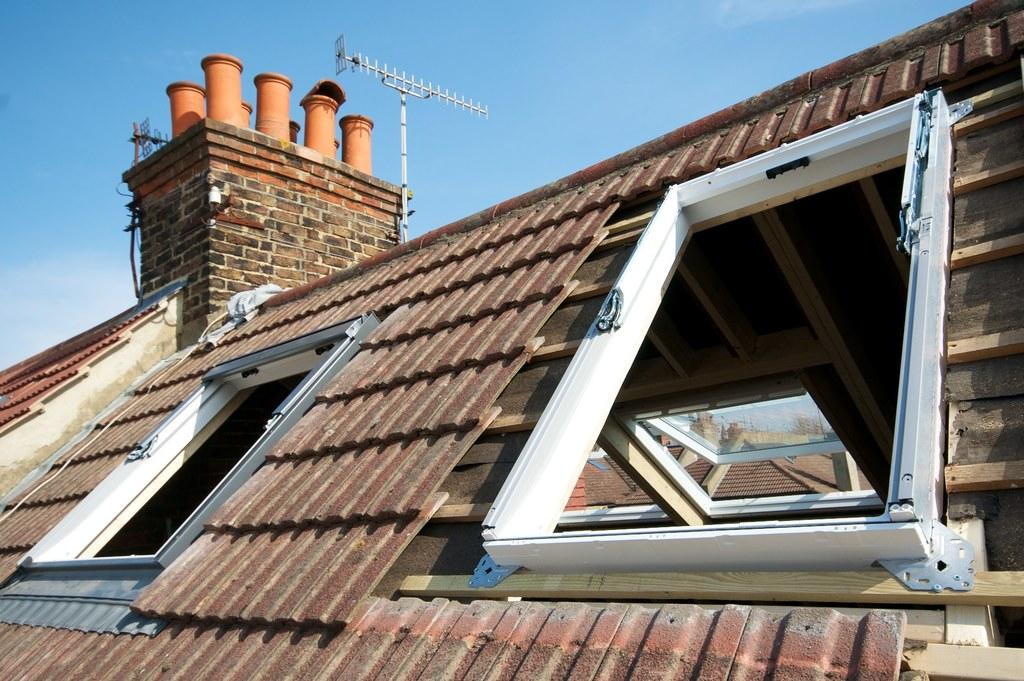What type of structures are present in the image? There are buildings in the image. What feature can be observed on the buildings? The buildings have glass windows. What additional object is present in the image? There is an antenna in the image. What can be seen in the background of the image? The sky is visible in the background of the image. What type of sail can be seen on the buildings in the image? There is no sail present on the buildings in the image; they are not ships or boats. 